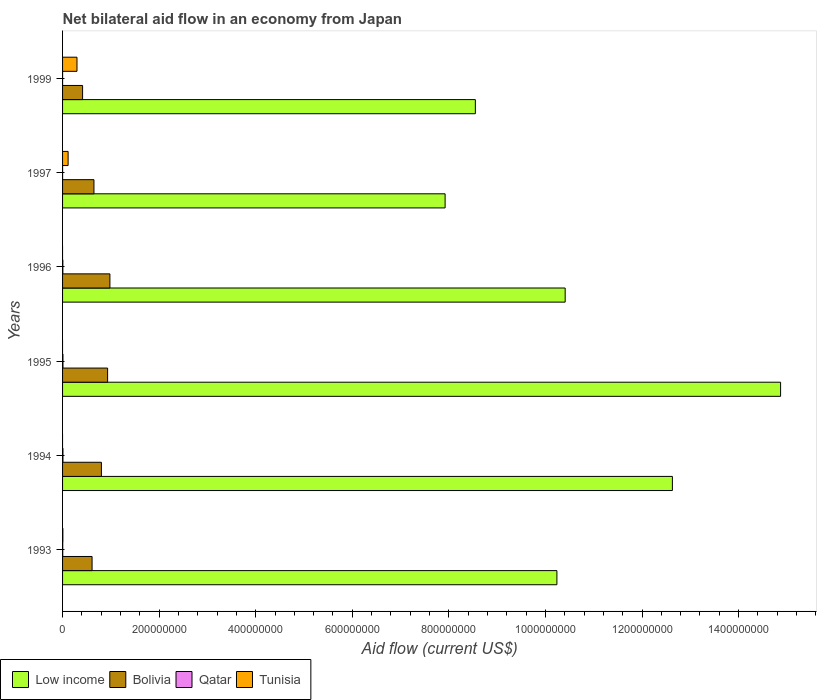How many different coloured bars are there?
Make the answer very short. 4. How many groups of bars are there?
Your answer should be very brief. 6. How many bars are there on the 6th tick from the bottom?
Make the answer very short. 4. What is the label of the 6th group of bars from the top?
Keep it short and to the point. 1993. In how many cases, is the number of bars for a given year not equal to the number of legend labels?
Your answer should be very brief. 3. What is the net bilateral aid flow in Qatar in 1997?
Ensure brevity in your answer.  2.00e+04. Across all years, what is the maximum net bilateral aid flow in Qatar?
Offer a very short reply. 8.00e+05. What is the total net bilateral aid flow in Low income in the graph?
Offer a terse response. 6.46e+09. What is the difference between the net bilateral aid flow in Bolivia in 1995 and that in 1999?
Your response must be concise. 5.18e+07. What is the difference between the net bilateral aid flow in Bolivia in 1993 and the net bilateral aid flow in Tunisia in 1995?
Give a very brief answer. 6.11e+07. What is the average net bilateral aid flow in Qatar per year?
Give a very brief answer. 4.30e+05. In the year 1994, what is the difference between the net bilateral aid flow in Bolivia and net bilateral aid flow in Low income?
Your answer should be compact. -1.18e+09. In how many years, is the net bilateral aid flow in Bolivia greater than 1320000000 US$?
Your response must be concise. 0. What is the ratio of the net bilateral aid flow in Bolivia in 1994 to that in 1999?
Provide a short and direct response. 1.94. What is the difference between the highest and the second highest net bilateral aid flow in Low income?
Make the answer very short. 2.24e+08. What is the difference between the highest and the lowest net bilateral aid flow in Tunisia?
Provide a short and direct response. 2.98e+07. Is it the case that in every year, the sum of the net bilateral aid flow in Low income and net bilateral aid flow in Qatar is greater than the net bilateral aid flow in Bolivia?
Provide a succinct answer. Yes. What is the difference between two consecutive major ticks on the X-axis?
Give a very brief answer. 2.00e+08. Are the values on the major ticks of X-axis written in scientific E-notation?
Provide a succinct answer. No. Does the graph contain any zero values?
Provide a short and direct response. Yes. Does the graph contain grids?
Give a very brief answer. No. How many legend labels are there?
Provide a short and direct response. 4. How are the legend labels stacked?
Offer a terse response. Horizontal. What is the title of the graph?
Offer a terse response. Net bilateral aid flow in an economy from Japan. What is the label or title of the Y-axis?
Ensure brevity in your answer.  Years. What is the Aid flow (current US$) of Low income in 1993?
Offer a terse response. 1.02e+09. What is the Aid flow (current US$) of Bolivia in 1993?
Provide a succinct answer. 6.11e+07. What is the Aid flow (current US$) in Tunisia in 1993?
Ensure brevity in your answer.  6.20e+05. What is the Aid flow (current US$) of Low income in 1994?
Ensure brevity in your answer.  1.26e+09. What is the Aid flow (current US$) of Bolivia in 1994?
Give a very brief answer. 8.04e+07. What is the Aid flow (current US$) of Qatar in 1994?
Your response must be concise. 7.80e+05. What is the Aid flow (current US$) in Low income in 1995?
Your answer should be very brief. 1.49e+09. What is the Aid flow (current US$) of Bolivia in 1995?
Give a very brief answer. 9.33e+07. What is the Aid flow (current US$) in Low income in 1996?
Make the answer very short. 1.04e+09. What is the Aid flow (current US$) of Bolivia in 1996?
Keep it short and to the point. 9.80e+07. What is the Aid flow (current US$) of Qatar in 1996?
Your response must be concise. 5.90e+05. What is the Aid flow (current US$) of Low income in 1997?
Your response must be concise. 7.92e+08. What is the Aid flow (current US$) of Bolivia in 1997?
Ensure brevity in your answer.  6.50e+07. What is the Aid flow (current US$) of Tunisia in 1997?
Give a very brief answer. 1.15e+07. What is the Aid flow (current US$) in Low income in 1999?
Make the answer very short. 8.55e+08. What is the Aid flow (current US$) in Bolivia in 1999?
Provide a succinct answer. 4.15e+07. What is the Aid flow (current US$) in Tunisia in 1999?
Provide a succinct answer. 2.98e+07. Across all years, what is the maximum Aid flow (current US$) of Low income?
Your answer should be compact. 1.49e+09. Across all years, what is the maximum Aid flow (current US$) of Bolivia?
Your response must be concise. 9.80e+07. Across all years, what is the maximum Aid flow (current US$) in Qatar?
Your answer should be very brief. 8.00e+05. Across all years, what is the maximum Aid flow (current US$) of Tunisia?
Your response must be concise. 2.98e+07. Across all years, what is the minimum Aid flow (current US$) of Low income?
Your response must be concise. 7.92e+08. Across all years, what is the minimum Aid flow (current US$) in Bolivia?
Ensure brevity in your answer.  4.15e+07. Across all years, what is the minimum Aid flow (current US$) in Qatar?
Keep it short and to the point. 2.00e+04. What is the total Aid flow (current US$) in Low income in the graph?
Provide a short and direct response. 6.46e+09. What is the total Aid flow (current US$) in Bolivia in the graph?
Offer a terse response. 4.39e+08. What is the total Aid flow (current US$) of Qatar in the graph?
Keep it short and to the point. 2.58e+06. What is the total Aid flow (current US$) of Tunisia in the graph?
Your answer should be very brief. 4.20e+07. What is the difference between the Aid flow (current US$) in Low income in 1993 and that in 1994?
Keep it short and to the point. -2.39e+08. What is the difference between the Aid flow (current US$) of Bolivia in 1993 and that in 1994?
Your answer should be compact. -1.93e+07. What is the difference between the Aid flow (current US$) of Qatar in 1993 and that in 1994?
Your answer should be compact. -4.20e+05. What is the difference between the Aid flow (current US$) of Low income in 1993 and that in 1995?
Provide a succinct answer. -4.63e+08. What is the difference between the Aid flow (current US$) in Bolivia in 1993 and that in 1995?
Give a very brief answer. -3.22e+07. What is the difference between the Aid flow (current US$) in Qatar in 1993 and that in 1995?
Your answer should be very brief. -4.40e+05. What is the difference between the Aid flow (current US$) of Low income in 1993 and that in 1996?
Provide a succinct answer. -1.71e+07. What is the difference between the Aid flow (current US$) of Bolivia in 1993 and that in 1996?
Make the answer very short. -3.69e+07. What is the difference between the Aid flow (current US$) in Qatar in 1993 and that in 1996?
Offer a terse response. -2.30e+05. What is the difference between the Aid flow (current US$) of Low income in 1993 and that in 1997?
Provide a succinct answer. 2.32e+08. What is the difference between the Aid flow (current US$) of Bolivia in 1993 and that in 1997?
Offer a terse response. -3.89e+06. What is the difference between the Aid flow (current US$) of Qatar in 1993 and that in 1997?
Offer a terse response. 3.40e+05. What is the difference between the Aid flow (current US$) of Tunisia in 1993 and that in 1997?
Make the answer very short. -1.09e+07. What is the difference between the Aid flow (current US$) of Low income in 1993 and that in 1999?
Your response must be concise. 1.69e+08. What is the difference between the Aid flow (current US$) in Bolivia in 1993 and that in 1999?
Keep it short and to the point. 1.96e+07. What is the difference between the Aid flow (current US$) in Tunisia in 1993 and that in 1999?
Offer a terse response. -2.92e+07. What is the difference between the Aid flow (current US$) of Low income in 1994 and that in 1995?
Your answer should be compact. -2.24e+08. What is the difference between the Aid flow (current US$) of Bolivia in 1994 and that in 1995?
Provide a short and direct response. -1.28e+07. What is the difference between the Aid flow (current US$) in Low income in 1994 and that in 1996?
Give a very brief answer. 2.22e+08. What is the difference between the Aid flow (current US$) of Bolivia in 1994 and that in 1996?
Keep it short and to the point. -1.76e+07. What is the difference between the Aid flow (current US$) of Qatar in 1994 and that in 1996?
Your answer should be very brief. 1.90e+05. What is the difference between the Aid flow (current US$) of Low income in 1994 and that in 1997?
Make the answer very short. 4.71e+08. What is the difference between the Aid flow (current US$) of Bolivia in 1994 and that in 1997?
Provide a succinct answer. 1.54e+07. What is the difference between the Aid flow (current US$) of Qatar in 1994 and that in 1997?
Your answer should be very brief. 7.60e+05. What is the difference between the Aid flow (current US$) of Low income in 1994 and that in 1999?
Ensure brevity in your answer.  4.08e+08. What is the difference between the Aid flow (current US$) in Bolivia in 1994 and that in 1999?
Offer a very short reply. 3.90e+07. What is the difference between the Aid flow (current US$) in Qatar in 1994 and that in 1999?
Your answer should be very brief. 7.50e+05. What is the difference between the Aid flow (current US$) of Low income in 1995 and that in 1996?
Give a very brief answer. 4.46e+08. What is the difference between the Aid flow (current US$) of Bolivia in 1995 and that in 1996?
Give a very brief answer. -4.75e+06. What is the difference between the Aid flow (current US$) of Qatar in 1995 and that in 1996?
Your answer should be very brief. 2.10e+05. What is the difference between the Aid flow (current US$) of Low income in 1995 and that in 1997?
Provide a succinct answer. 6.95e+08. What is the difference between the Aid flow (current US$) in Bolivia in 1995 and that in 1997?
Offer a very short reply. 2.83e+07. What is the difference between the Aid flow (current US$) in Qatar in 1995 and that in 1997?
Provide a short and direct response. 7.80e+05. What is the difference between the Aid flow (current US$) in Low income in 1995 and that in 1999?
Keep it short and to the point. 6.32e+08. What is the difference between the Aid flow (current US$) of Bolivia in 1995 and that in 1999?
Offer a terse response. 5.18e+07. What is the difference between the Aid flow (current US$) of Qatar in 1995 and that in 1999?
Ensure brevity in your answer.  7.70e+05. What is the difference between the Aid flow (current US$) of Low income in 1996 and that in 1997?
Give a very brief answer. 2.49e+08. What is the difference between the Aid flow (current US$) of Bolivia in 1996 and that in 1997?
Offer a terse response. 3.30e+07. What is the difference between the Aid flow (current US$) of Qatar in 1996 and that in 1997?
Offer a very short reply. 5.70e+05. What is the difference between the Aid flow (current US$) of Low income in 1996 and that in 1999?
Your answer should be compact. 1.86e+08. What is the difference between the Aid flow (current US$) of Bolivia in 1996 and that in 1999?
Offer a terse response. 5.65e+07. What is the difference between the Aid flow (current US$) in Qatar in 1996 and that in 1999?
Make the answer very short. 5.60e+05. What is the difference between the Aid flow (current US$) of Low income in 1997 and that in 1999?
Your response must be concise. -6.26e+07. What is the difference between the Aid flow (current US$) in Bolivia in 1997 and that in 1999?
Your answer should be very brief. 2.35e+07. What is the difference between the Aid flow (current US$) of Qatar in 1997 and that in 1999?
Keep it short and to the point. -10000. What is the difference between the Aid flow (current US$) of Tunisia in 1997 and that in 1999?
Offer a very short reply. -1.84e+07. What is the difference between the Aid flow (current US$) of Low income in 1993 and the Aid flow (current US$) of Bolivia in 1994?
Give a very brief answer. 9.43e+08. What is the difference between the Aid flow (current US$) in Low income in 1993 and the Aid flow (current US$) in Qatar in 1994?
Ensure brevity in your answer.  1.02e+09. What is the difference between the Aid flow (current US$) of Bolivia in 1993 and the Aid flow (current US$) of Qatar in 1994?
Offer a very short reply. 6.03e+07. What is the difference between the Aid flow (current US$) in Low income in 1993 and the Aid flow (current US$) in Bolivia in 1995?
Make the answer very short. 9.30e+08. What is the difference between the Aid flow (current US$) of Low income in 1993 and the Aid flow (current US$) of Qatar in 1995?
Your answer should be very brief. 1.02e+09. What is the difference between the Aid flow (current US$) of Bolivia in 1993 and the Aid flow (current US$) of Qatar in 1995?
Provide a short and direct response. 6.03e+07. What is the difference between the Aid flow (current US$) of Low income in 1993 and the Aid flow (current US$) of Bolivia in 1996?
Provide a succinct answer. 9.26e+08. What is the difference between the Aid flow (current US$) of Low income in 1993 and the Aid flow (current US$) of Qatar in 1996?
Provide a succinct answer. 1.02e+09. What is the difference between the Aid flow (current US$) in Bolivia in 1993 and the Aid flow (current US$) in Qatar in 1996?
Keep it short and to the point. 6.05e+07. What is the difference between the Aid flow (current US$) in Low income in 1993 and the Aid flow (current US$) in Bolivia in 1997?
Ensure brevity in your answer.  9.59e+08. What is the difference between the Aid flow (current US$) in Low income in 1993 and the Aid flow (current US$) in Qatar in 1997?
Offer a very short reply. 1.02e+09. What is the difference between the Aid flow (current US$) of Low income in 1993 and the Aid flow (current US$) of Tunisia in 1997?
Your response must be concise. 1.01e+09. What is the difference between the Aid flow (current US$) in Bolivia in 1993 and the Aid flow (current US$) in Qatar in 1997?
Offer a terse response. 6.11e+07. What is the difference between the Aid flow (current US$) of Bolivia in 1993 and the Aid flow (current US$) of Tunisia in 1997?
Keep it short and to the point. 4.96e+07. What is the difference between the Aid flow (current US$) in Qatar in 1993 and the Aid flow (current US$) in Tunisia in 1997?
Provide a short and direct response. -1.11e+07. What is the difference between the Aid flow (current US$) in Low income in 1993 and the Aid flow (current US$) in Bolivia in 1999?
Provide a short and direct response. 9.82e+08. What is the difference between the Aid flow (current US$) of Low income in 1993 and the Aid flow (current US$) of Qatar in 1999?
Ensure brevity in your answer.  1.02e+09. What is the difference between the Aid flow (current US$) of Low income in 1993 and the Aid flow (current US$) of Tunisia in 1999?
Your answer should be very brief. 9.94e+08. What is the difference between the Aid flow (current US$) of Bolivia in 1993 and the Aid flow (current US$) of Qatar in 1999?
Give a very brief answer. 6.11e+07. What is the difference between the Aid flow (current US$) of Bolivia in 1993 and the Aid flow (current US$) of Tunisia in 1999?
Keep it short and to the point. 3.13e+07. What is the difference between the Aid flow (current US$) of Qatar in 1993 and the Aid flow (current US$) of Tunisia in 1999?
Your response must be concise. -2.95e+07. What is the difference between the Aid flow (current US$) of Low income in 1994 and the Aid flow (current US$) of Bolivia in 1995?
Make the answer very short. 1.17e+09. What is the difference between the Aid flow (current US$) in Low income in 1994 and the Aid flow (current US$) in Qatar in 1995?
Make the answer very short. 1.26e+09. What is the difference between the Aid flow (current US$) of Bolivia in 1994 and the Aid flow (current US$) of Qatar in 1995?
Make the answer very short. 7.96e+07. What is the difference between the Aid flow (current US$) in Low income in 1994 and the Aid flow (current US$) in Bolivia in 1996?
Your response must be concise. 1.16e+09. What is the difference between the Aid flow (current US$) of Low income in 1994 and the Aid flow (current US$) of Qatar in 1996?
Ensure brevity in your answer.  1.26e+09. What is the difference between the Aid flow (current US$) of Bolivia in 1994 and the Aid flow (current US$) of Qatar in 1996?
Offer a very short reply. 7.98e+07. What is the difference between the Aid flow (current US$) of Low income in 1994 and the Aid flow (current US$) of Bolivia in 1997?
Ensure brevity in your answer.  1.20e+09. What is the difference between the Aid flow (current US$) of Low income in 1994 and the Aid flow (current US$) of Qatar in 1997?
Your response must be concise. 1.26e+09. What is the difference between the Aid flow (current US$) in Low income in 1994 and the Aid flow (current US$) in Tunisia in 1997?
Keep it short and to the point. 1.25e+09. What is the difference between the Aid flow (current US$) in Bolivia in 1994 and the Aid flow (current US$) in Qatar in 1997?
Your answer should be very brief. 8.04e+07. What is the difference between the Aid flow (current US$) in Bolivia in 1994 and the Aid flow (current US$) in Tunisia in 1997?
Offer a terse response. 6.90e+07. What is the difference between the Aid flow (current US$) of Qatar in 1994 and the Aid flow (current US$) of Tunisia in 1997?
Your answer should be very brief. -1.07e+07. What is the difference between the Aid flow (current US$) of Low income in 1994 and the Aid flow (current US$) of Bolivia in 1999?
Your answer should be compact. 1.22e+09. What is the difference between the Aid flow (current US$) in Low income in 1994 and the Aid flow (current US$) in Qatar in 1999?
Make the answer very short. 1.26e+09. What is the difference between the Aid flow (current US$) of Low income in 1994 and the Aid flow (current US$) of Tunisia in 1999?
Offer a terse response. 1.23e+09. What is the difference between the Aid flow (current US$) of Bolivia in 1994 and the Aid flow (current US$) of Qatar in 1999?
Offer a very short reply. 8.04e+07. What is the difference between the Aid flow (current US$) in Bolivia in 1994 and the Aid flow (current US$) in Tunisia in 1999?
Provide a short and direct response. 5.06e+07. What is the difference between the Aid flow (current US$) in Qatar in 1994 and the Aid flow (current US$) in Tunisia in 1999?
Provide a succinct answer. -2.91e+07. What is the difference between the Aid flow (current US$) of Low income in 1995 and the Aid flow (current US$) of Bolivia in 1996?
Ensure brevity in your answer.  1.39e+09. What is the difference between the Aid flow (current US$) in Low income in 1995 and the Aid flow (current US$) in Qatar in 1996?
Offer a terse response. 1.49e+09. What is the difference between the Aid flow (current US$) of Bolivia in 1995 and the Aid flow (current US$) of Qatar in 1996?
Offer a terse response. 9.27e+07. What is the difference between the Aid flow (current US$) of Low income in 1995 and the Aid flow (current US$) of Bolivia in 1997?
Your answer should be compact. 1.42e+09. What is the difference between the Aid flow (current US$) of Low income in 1995 and the Aid flow (current US$) of Qatar in 1997?
Your response must be concise. 1.49e+09. What is the difference between the Aid flow (current US$) of Low income in 1995 and the Aid flow (current US$) of Tunisia in 1997?
Offer a terse response. 1.48e+09. What is the difference between the Aid flow (current US$) in Bolivia in 1995 and the Aid flow (current US$) in Qatar in 1997?
Offer a very short reply. 9.33e+07. What is the difference between the Aid flow (current US$) in Bolivia in 1995 and the Aid flow (current US$) in Tunisia in 1997?
Offer a very short reply. 8.18e+07. What is the difference between the Aid flow (current US$) in Qatar in 1995 and the Aid flow (current US$) in Tunisia in 1997?
Offer a very short reply. -1.07e+07. What is the difference between the Aid flow (current US$) in Low income in 1995 and the Aid flow (current US$) in Bolivia in 1999?
Give a very brief answer. 1.45e+09. What is the difference between the Aid flow (current US$) in Low income in 1995 and the Aid flow (current US$) in Qatar in 1999?
Give a very brief answer. 1.49e+09. What is the difference between the Aid flow (current US$) in Low income in 1995 and the Aid flow (current US$) in Tunisia in 1999?
Keep it short and to the point. 1.46e+09. What is the difference between the Aid flow (current US$) of Bolivia in 1995 and the Aid flow (current US$) of Qatar in 1999?
Your answer should be very brief. 9.32e+07. What is the difference between the Aid flow (current US$) in Bolivia in 1995 and the Aid flow (current US$) in Tunisia in 1999?
Give a very brief answer. 6.34e+07. What is the difference between the Aid flow (current US$) in Qatar in 1995 and the Aid flow (current US$) in Tunisia in 1999?
Offer a terse response. -2.90e+07. What is the difference between the Aid flow (current US$) of Low income in 1996 and the Aid flow (current US$) of Bolivia in 1997?
Provide a succinct answer. 9.76e+08. What is the difference between the Aid flow (current US$) of Low income in 1996 and the Aid flow (current US$) of Qatar in 1997?
Keep it short and to the point. 1.04e+09. What is the difference between the Aid flow (current US$) in Low income in 1996 and the Aid flow (current US$) in Tunisia in 1997?
Your answer should be compact. 1.03e+09. What is the difference between the Aid flow (current US$) in Bolivia in 1996 and the Aid flow (current US$) in Qatar in 1997?
Offer a terse response. 9.80e+07. What is the difference between the Aid flow (current US$) in Bolivia in 1996 and the Aid flow (current US$) in Tunisia in 1997?
Provide a succinct answer. 8.66e+07. What is the difference between the Aid flow (current US$) in Qatar in 1996 and the Aid flow (current US$) in Tunisia in 1997?
Give a very brief answer. -1.09e+07. What is the difference between the Aid flow (current US$) of Low income in 1996 and the Aid flow (current US$) of Bolivia in 1999?
Keep it short and to the point. 9.99e+08. What is the difference between the Aid flow (current US$) in Low income in 1996 and the Aid flow (current US$) in Qatar in 1999?
Your answer should be very brief. 1.04e+09. What is the difference between the Aid flow (current US$) of Low income in 1996 and the Aid flow (current US$) of Tunisia in 1999?
Offer a very short reply. 1.01e+09. What is the difference between the Aid flow (current US$) in Bolivia in 1996 and the Aid flow (current US$) in Qatar in 1999?
Make the answer very short. 9.80e+07. What is the difference between the Aid flow (current US$) in Bolivia in 1996 and the Aid flow (current US$) in Tunisia in 1999?
Your answer should be very brief. 6.82e+07. What is the difference between the Aid flow (current US$) in Qatar in 1996 and the Aid flow (current US$) in Tunisia in 1999?
Provide a short and direct response. -2.93e+07. What is the difference between the Aid flow (current US$) of Low income in 1997 and the Aid flow (current US$) of Bolivia in 1999?
Your response must be concise. 7.51e+08. What is the difference between the Aid flow (current US$) in Low income in 1997 and the Aid flow (current US$) in Qatar in 1999?
Your answer should be compact. 7.92e+08. What is the difference between the Aid flow (current US$) in Low income in 1997 and the Aid flow (current US$) in Tunisia in 1999?
Your answer should be very brief. 7.62e+08. What is the difference between the Aid flow (current US$) of Bolivia in 1997 and the Aid flow (current US$) of Qatar in 1999?
Provide a succinct answer. 6.50e+07. What is the difference between the Aid flow (current US$) of Bolivia in 1997 and the Aid flow (current US$) of Tunisia in 1999?
Your answer should be very brief. 3.52e+07. What is the difference between the Aid flow (current US$) of Qatar in 1997 and the Aid flow (current US$) of Tunisia in 1999?
Offer a terse response. -2.98e+07. What is the average Aid flow (current US$) in Low income per year?
Your answer should be compact. 1.08e+09. What is the average Aid flow (current US$) of Bolivia per year?
Ensure brevity in your answer.  7.32e+07. What is the average Aid flow (current US$) in Tunisia per year?
Keep it short and to the point. 6.99e+06. In the year 1993, what is the difference between the Aid flow (current US$) in Low income and Aid flow (current US$) in Bolivia?
Your response must be concise. 9.63e+08. In the year 1993, what is the difference between the Aid flow (current US$) of Low income and Aid flow (current US$) of Qatar?
Make the answer very short. 1.02e+09. In the year 1993, what is the difference between the Aid flow (current US$) in Low income and Aid flow (current US$) in Tunisia?
Provide a short and direct response. 1.02e+09. In the year 1993, what is the difference between the Aid flow (current US$) of Bolivia and Aid flow (current US$) of Qatar?
Give a very brief answer. 6.08e+07. In the year 1993, what is the difference between the Aid flow (current US$) of Bolivia and Aid flow (current US$) of Tunisia?
Your answer should be very brief. 6.05e+07. In the year 1994, what is the difference between the Aid flow (current US$) in Low income and Aid flow (current US$) in Bolivia?
Provide a short and direct response. 1.18e+09. In the year 1994, what is the difference between the Aid flow (current US$) of Low income and Aid flow (current US$) of Qatar?
Offer a terse response. 1.26e+09. In the year 1994, what is the difference between the Aid flow (current US$) in Bolivia and Aid flow (current US$) in Qatar?
Your response must be concise. 7.97e+07. In the year 1995, what is the difference between the Aid flow (current US$) of Low income and Aid flow (current US$) of Bolivia?
Ensure brevity in your answer.  1.39e+09. In the year 1995, what is the difference between the Aid flow (current US$) of Low income and Aid flow (current US$) of Qatar?
Offer a terse response. 1.49e+09. In the year 1995, what is the difference between the Aid flow (current US$) in Bolivia and Aid flow (current US$) in Qatar?
Give a very brief answer. 9.25e+07. In the year 1996, what is the difference between the Aid flow (current US$) in Low income and Aid flow (current US$) in Bolivia?
Offer a very short reply. 9.43e+08. In the year 1996, what is the difference between the Aid flow (current US$) in Low income and Aid flow (current US$) in Qatar?
Keep it short and to the point. 1.04e+09. In the year 1996, what is the difference between the Aid flow (current US$) of Bolivia and Aid flow (current US$) of Qatar?
Offer a very short reply. 9.74e+07. In the year 1997, what is the difference between the Aid flow (current US$) of Low income and Aid flow (current US$) of Bolivia?
Keep it short and to the point. 7.27e+08. In the year 1997, what is the difference between the Aid flow (current US$) in Low income and Aid flow (current US$) in Qatar?
Your answer should be very brief. 7.92e+08. In the year 1997, what is the difference between the Aid flow (current US$) in Low income and Aid flow (current US$) in Tunisia?
Keep it short and to the point. 7.81e+08. In the year 1997, what is the difference between the Aid flow (current US$) in Bolivia and Aid flow (current US$) in Qatar?
Your answer should be very brief. 6.50e+07. In the year 1997, what is the difference between the Aid flow (current US$) of Bolivia and Aid flow (current US$) of Tunisia?
Your answer should be compact. 5.35e+07. In the year 1997, what is the difference between the Aid flow (current US$) in Qatar and Aid flow (current US$) in Tunisia?
Give a very brief answer. -1.15e+07. In the year 1999, what is the difference between the Aid flow (current US$) of Low income and Aid flow (current US$) of Bolivia?
Offer a very short reply. 8.13e+08. In the year 1999, what is the difference between the Aid flow (current US$) of Low income and Aid flow (current US$) of Qatar?
Your answer should be very brief. 8.55e+08. In the year 1999, what is the difference between the Aid flow (current US$) of Low income and Aid flow (current US$) of Tunisia?
Provide a succinct answer. 8.25e+08. In the year 1999, what is the difference between the Aid flow (current US$) in Bolivia and Aid flow (current US$) in Qatar?
Give a very brief answer. 4.15e+07. In the year 1999, what is the difference between the Aid flow (current US$) in Bolivia and Aid flow (current US$) in Tunisia?
Provide a short and direct response. 1.16e+07. In the year 1999, what is the difference between the Aid flow (current US$) of Qatar and Aid flow (current US$) of Tunisia?
Make the answer very short. -2.98e+07. What is the ratio of the Aid flow (current US$) in Low income in 1993 to that in 1994?
Keep it short and to the point. 0.81. What is the ratio of the Aid flow (current US$) of Bolivia in 1993 to that in 1994?
Offer a terse response. 0.76. What is the ratio of the Aid flow (current US$) in Qatar in 1993 to that in 1994?
Make the answer very short. 0.46. What is the ratio of the Aid flow (current US$) in Low income in 1993 to that in 1995?
Provide a succinct answer. 0.69. What is the ratio of the Aid flow (current US$) in Bolivia in 1993 to that in 1995?
Offer a very short reply. 0.66. What is the ratio of the Aid flow (current US$) of Qatar in 1993 to that in 1995?
Ensure brevity in your answer.  0.45. What is the ratio of the Aid flow (current US$) of Low income in 1993 to that in 1996?
Ensure brevity in your answer.  0.98. What is the ratio of the Aid flow (current US$) in Bolivia in 1993 to that in 1996?
Provide a succinct answer. 0.62. What is the ratio of the Aid flow (current US$) of Qatar in 1993 to that in 1996?
Your answer should be very brief. 0.61. What is the ratio of the Aid flow (current US$) in Low income in 1993 to that in 1997?
Keep it short and to the point. 1.29. What is the ratio of the Aid flow (current US$) in Bolivia in 1993 to that in 1997?
Provide a succinct answer. 0.94. What is the ratio of the Aid flow (current US$) of Tunisia in 1993 to that in 1997?
Provide a short and direct response. 0.05. What is the ratio of the Aid flow (current US$) in Low income in 1993 to that in 1999?
Make the answer very short. 1.2. What is the ratio of the Aid flow (current US$) in Bolivia in 1993 to that in 1999?
Offer a very short reply. 1.47. What is the ratio of the Aid flow (current US$) of Qatar in 1993 to that in 1999?
Your response must be concise. 12. What is the ratio of the Aid flow (current US$) in Tunisia in 1993 to that in 1999?
Offer a terse response. 0.02. What is the ratio of the Aid flow (current US$) of Low income in 1994 to that in 1995?
Offer a very short reply. 0.85. What is the ratio of the Aid flow (current US$) in Bolivia in 1994 to that in 1995?
Offer a very short reply. 0.86. What is the ratio of the Aid flow (current US$) in Qatar in 1994 to that in 1995?
Provide a short and direct response. 0.97. What is the ratio of the Aid flow (current US$) of Low income in 1994 to that in 1996?
Offer a terse response. 1.21. What is the ratio of the Aid flow (current US$) in Bolivia in 1994 to that in 1996?
Offer a very short reply. 0.82. What is the ratio of the Aid flow (current US$) of Qatar in 1994 to that in 1996?
Offer a very short reply. 1.32. What is the ratio of the Aid flow (current US$) in Low income in 1994 to that in 1997?
Keep it short and to the point. 1.59. What is the ratio of the Aid flow (current US$) in Bolivia in 1994 to that in 1997?
Ensure brevity in your answer.  1.24. What is the ratio of the Aid flow (current US$) of Qatar in 1994 to that in 1997?
Your answer should be very brief. 39. What is the ratio of the Aid flow (current US$) in Low income in 1994 to that in 1999?
Offer a very short reply. 1.48. What is the ratio of the Aid flow (current US$) in Bolivia in 1994 to that in 1999?
Keep it short and to the point. 1.94. What is the ratio of the Aid flow (current US$) in Low income in 1995 to that in 1996?
Ensure brevity in your answer.  1.43. What is the ratio of the Aid flow (current US$) of Bolivia in 1995 to that in 1996?
Offer a terse response. 0.95. What is the ratio of the Aid flow (current US$) in Qatar in 1995 to that in 1996?
Keep it short and to the point. 1.36. What is the ratio of the Aid flow (current US$) of Low income in 1995 to that in 1997?
Make the answer very short. 1.88. What is the ratio of the Aid flow (current US$) of Bolivia in 1995 to that in 1997?
Your response must be concise. 1.44. What is the ratio of the Aid flow (current US$) in Qatar in 1995 to that in 1997?
Keep it short and to the point. 40. What is the ratio of the Aid flow (current US$) of Low income in 1995 to that in 1999?
Make the answer very short. 1.74. What is the ratio of the Aid flow (current US$) in Bolivia in 1995 to that in 1999?
Your answer should be very brief. 2.25. What is the ratio of the Aid flow (current US$) in Qatar in 1995 to that in 1999?
Ensure brevity in your answer.  26.67. What is the ratio of the Aid flow (current US$) in Low income in 1996 to that in 1997?
Offer a very short reply. 1.31. What is the ratio of the Aid flow (current US$) in Bolivia in 1996 to that in 1997?
Your answer should be compact. 1.51. What is the ratio of the Aid flow (current US$) in Qatar in 1996 to that in 1997?
Offer a terse response. 29.5. What is the ratio of the Aid flow (current US$) in Low income in 1996 to that in 1999?
Provide a succinct answer. 1.22. What is the ratio of the Aid flow (current US$) of Bolivia in 1996 to that in 1999?
Give a very brief answer. 2.36. What is the ratio of the Aid flow (current US$) in Qatar in 1996 to that in 1999?
Give a very brief answer. 19.67. What is the ratio of the Aid flow (current US$) of Low income in 1997 to that in 1999?
Make the answer very short. 0.93. What is the ratio of the Aid flow (current US$) of Bolivia in 1997 to that in 1999?
Offer a terse response. 1.57. What is the ratio of the Aid flow (current US$) in Tunisia in 1997 to that in 1999?
Make the answer very short. 0.38. What is the difference between the highest and the second highest Aid flow (current US$) in Low income?
Provide a succinct answer. 2.24e+08. What is the difference between the highest and the second highest Aid flow (current US$) in Bolivia?
Make the answer very short. 4.75e+06. What is the difference between the highest and the second highest Aid flow (current US$) in Qatar?
Offer a terse response. 2.00e+04. What is the difference between the highest and the second highest Aid flow (current US$) of Tunisia?
Make the answer very short. 1.84e+07. What is the difference between the highest and the lowest Aid flow (current US$) in Low income?
Provide a short and direct response. 6.95e+08. What is the difference between the highest and the lowest Aid flow (current US$) in Bolivia?
Offer a terse response. 5.65e+07. What is the difference between the highest and the lowest Aid flow (current US$) of Qatar?
Offer a terse response. 7.80e+05. What is the difference between the highest and the lowest Aid flow (current US$) in Tunisia?
Keep it short and to the point. 2.98e+07. 